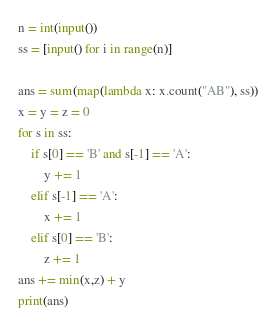<code> <loc_0><loc_0><loc_500><loc_500><_Python_>n = int(input())
ss = [input() for i in range(n)]

ans = sum(map(lambda x: x.count("AB"), ss))
x = y = z = 0
for s in ss:
    if s[0] == 'B' and s[-1] == 'A':
        y += 1
    elif s[-1] == 'A':
        x += 1
    elif s[0] == 'B':
        z += 1
ans += min(x,z) + y
print(ans)</code> 